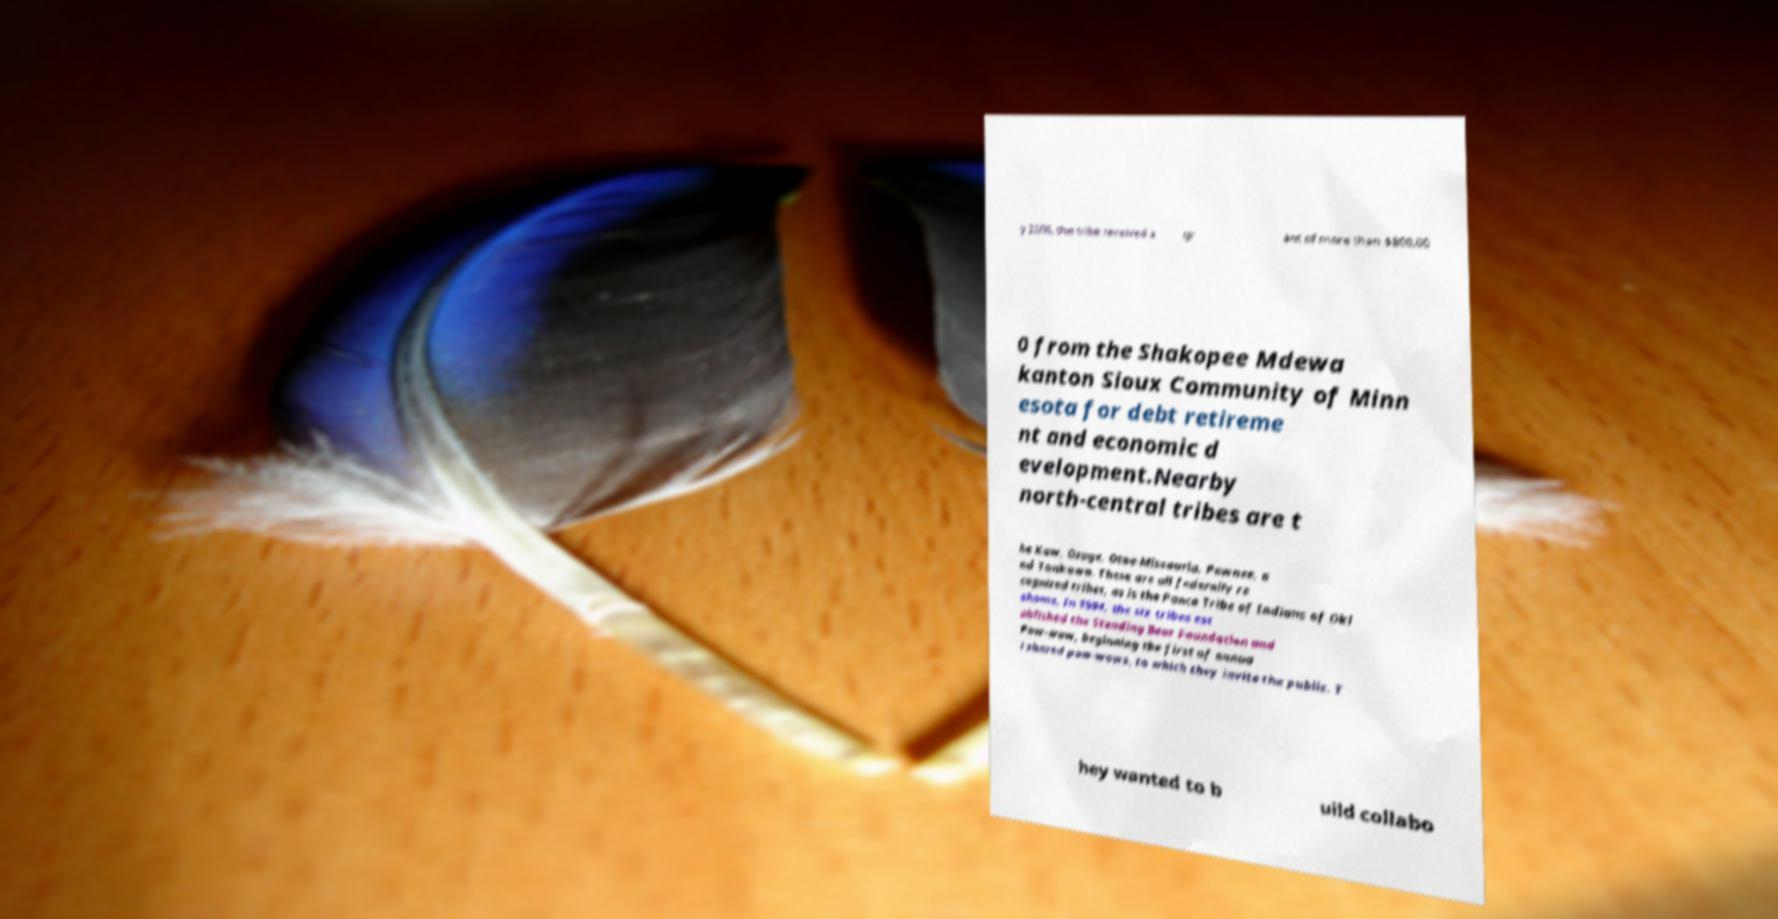Please read and relay the text visible in this image. What does it say? y 2006, the tribe received a gr ant of more than $800,00 0 from the Shakopee Mdewa kanton Sioux Community of Minn esota for debt retireme nt and economic d evelopment.Nearby north-central tribes are t he Kaw, Osage, Otoe-Missouria, Pawnee, a nd Tonkawa. These are all federally re cognized tribes, as is the Ponca Tribe of Indians of Okl ahoma. In 1994, the six tribes est ablished the Standing Bear Foundation and Pow-wow, beginning the first of annua l shared pow-wows, to which they invite the public. T hey wanted to b uild collabo 